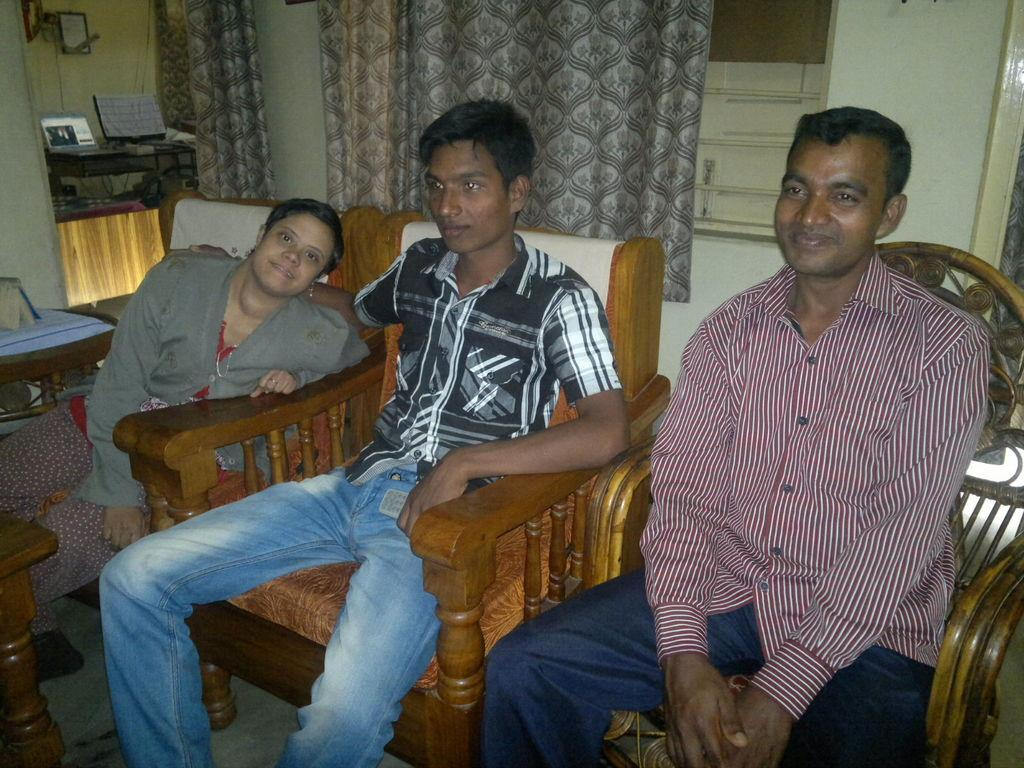How many people are in the image? There are three persons in the image. What are the persons doing in the image? The persons are sitting on chairs. What can be seen in the background of the image? There are curtains, a window, and a wall in the background of the image. Where are the objects located in the image? The objects are on the left side of the image. What type of tooth is visible in the image? There is no tooth present in the image. How does the fog affect the visibility of the persons in the image? There is no fog present in the image, so it does not affect the visibility of the persons. 